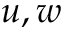Convert formula to latex. <formula><loc_0><loc_0><loc_500><loc_500>u , w</formula> 